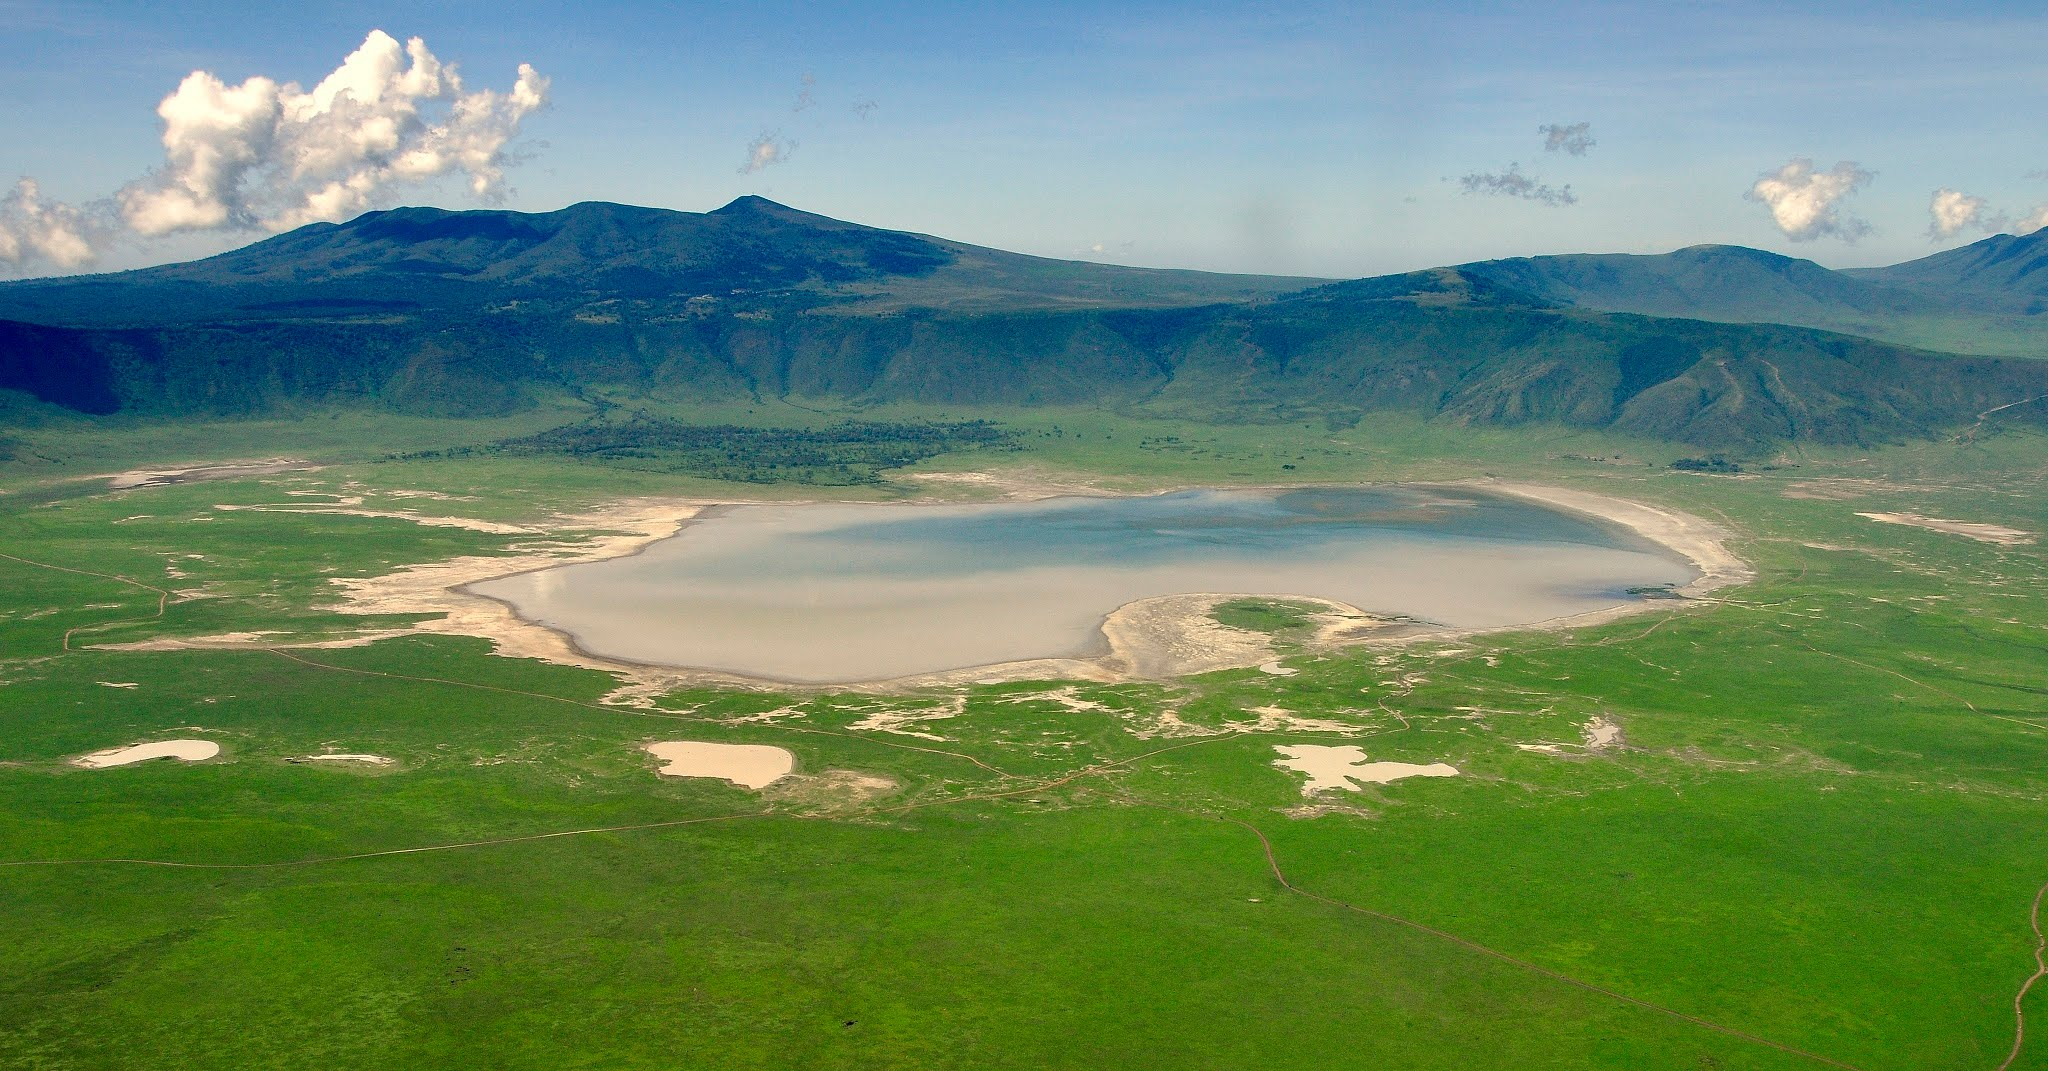What conservation challenges does the Ngorongoro Crater face? While the Ngorongoro Crater is a conservation success in many regards, it faces a set of unique challenges. Human-wildlife conflict is a prime concern as the local Maasai people graze their livestock within the crater, potentially leading to overgrazing and water sources' depletion. Additionally, the limited gene pool for certain species within the crater can lead to inbreeding and make populations vulnerable to diseases. The growing number of tourists also puts pressure on the ecosystem, potentially leading to habitat degradation. Conservationists balance the needs of wildlife, local people, and tourism to maintain this delicate ecosystem. Efforts include controlled grazing, anti-poaching patrols, and managing tourist numbers, all essential to preserve this magnificent natural wonder. 